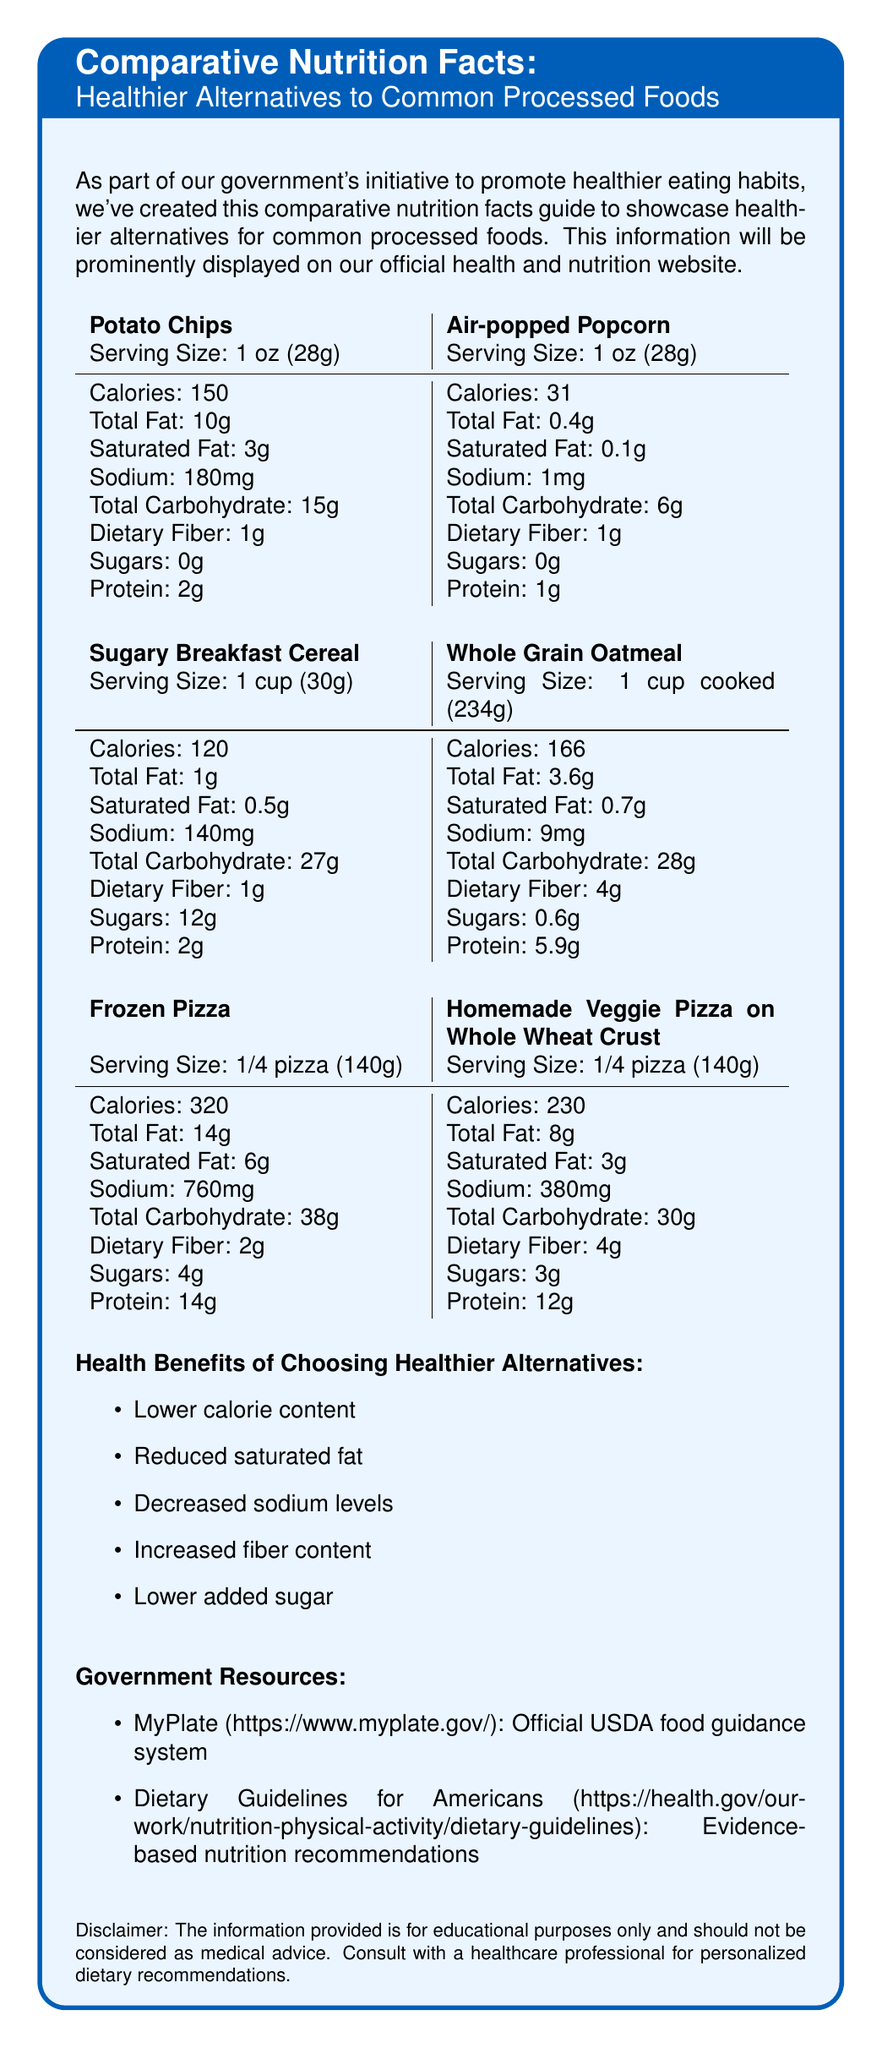What is the serving size for Potato Chips? The document shows the serving size of Potato Chips as "1 oz (28g)".
Answer: 1 oz (28g) How many calories are in 1 oz of Air-popped Popcorn? The document specifies that Air-popped Popcorn contains 31 calories per 1 oz serving size.
Answer: 31 What is the sodium content in a serving of Frozen Pizza? The nutritional information for Frozen Pizza lists the sodium content as 760 mg per serving.
Answer: 760 mg Which alternative has a higher dietary fiber content: Sugary Breakfast Cereal or Whole Grain Oatmeal? Whole Grain Oatmeal has 4g of dietary fiber per serving, whereas Sugary Breakfast Cereal has only 1g.
Answer: Whole Grain Oatmeal List one health benefit of choosing healthier alternatives from the document. One of the listed health benefits of choosing healthier alternatives is "Increased fiber content".
Answer: Increased fiber content Which healthier alternative is suggested in place of Sugary Breakfast Cereal? A. Whole Grain Oatmeal B. Air-popped Popcorn C. Homemade Veggie Pizza on Whole Wheat Crust D. Fresh Fruit Salad The document recommends Whole Grain Oatmeal as a healthier alternative to Sugary Breakfast Cereal.
Answer: A Select the food item with the lowest total fat content per serving. A. Potato Chips B. Air-popped Popcorn C. Sugary Breakfast Cereal D. Homemade Veggie Pizza on Whole Wheat Crust Air-popped Popcorn has the lowest total fat content, with only 0.4g per serving.
Answer: B Does the document provide a link to the Official USDA food guidance system? The document includes a resource link to MyPlate, the official USDA food guidance system.
Answer: Yes Summarize the main purpose of the document. The document is part of a government initiative to guide people towards healthier eating habits. It provides detailed nutritional comparisons between common processed foods and their healthier alternatives, highlights their health benefits, and offers links to reputable government resources.
Answer: The document aims to promote healthier eating habits by comparing the nutrition facts of common processed foods with healthier alternatives, highlighting their health benefits, and providing useful government resources. What is the flavor profile comparison between Potato Chips and Air-popped Popcorn? The document does not provide information regarding the flavor profiles of Potato Chips and Air-popped Popcorn.
Answer: Not enough information 